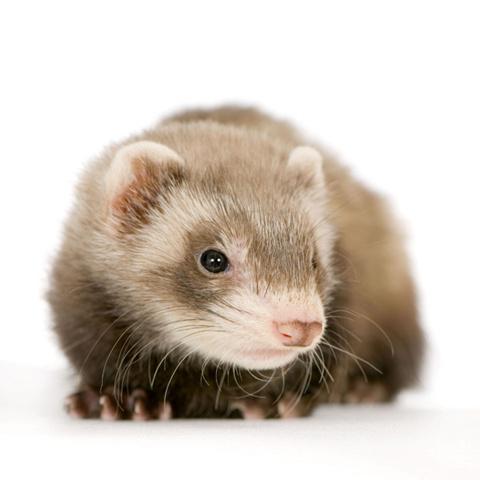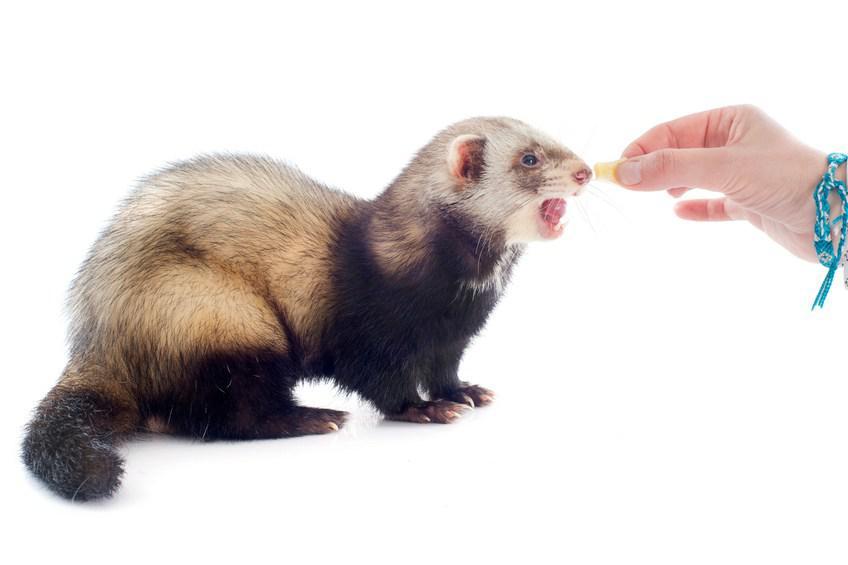The first image is the image on the left, the second image is the image on the right. Analyze the images presented: Is the assertion "One image shows a ferret standing behind a bowl of food, with its tail extending to the left and its head turned leftward." valid? Answer yes or no. No. The first image is the image on the left, the second image is the image on the right. For the images shown, is this caption "A ferret is eating out of a dish." true? Answer yes or no. No. 